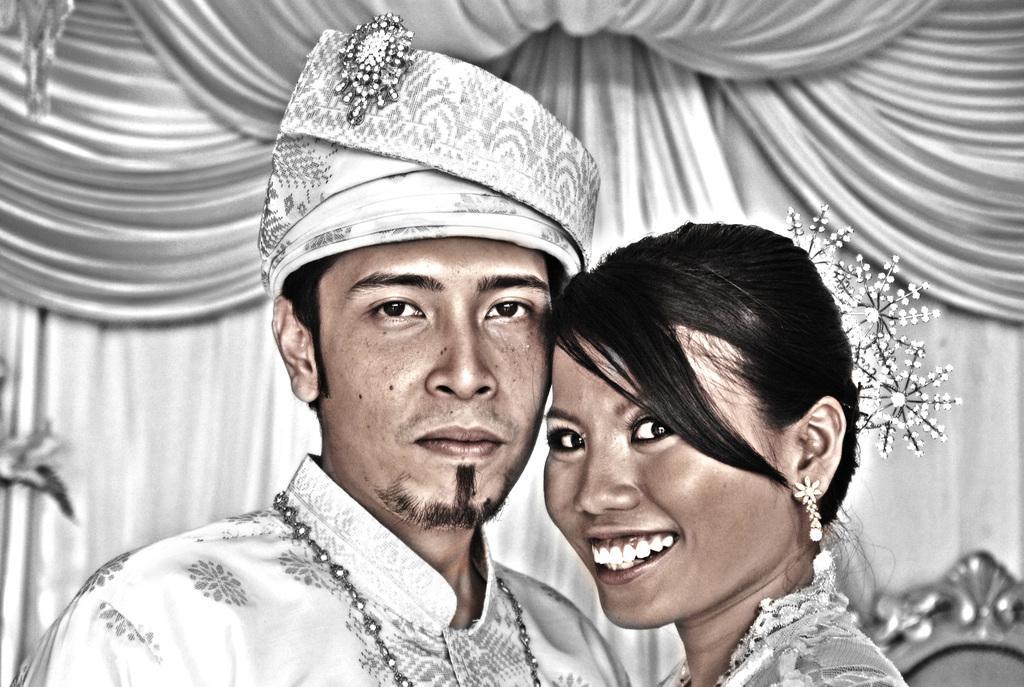In one or two sentences, can you explain what this image depicts? This is an edited picture. I can see a man and a woman, and in the background there are curtains. 